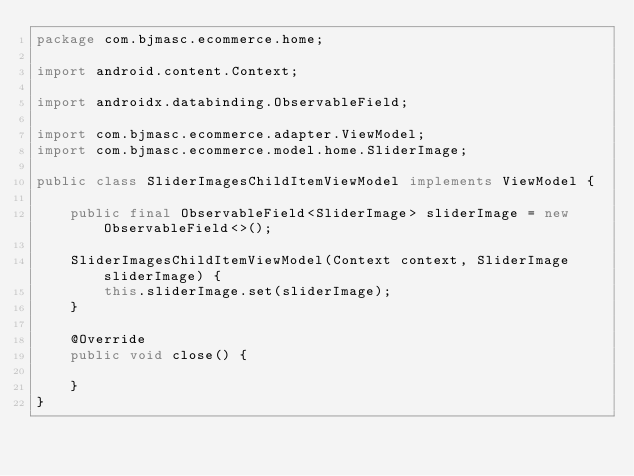Convert code to text. <code><loc_0><loc_0><loc_500><loc_500><_Java_>package com.bjmasc.ecommerce.home;

import android.content.Context;

import androidx.databinding.ObservableField;

import com.bjmasc.ecommerce.adapter.ViewModel;
import com.bjmasc.ecommerce.model.home.SliderImage;

public class SliderImagesChildItemViewModel implements ViewModel {

    public final ObservableField<SliderImage> sliderImage = new ObservableField<>();

    SliderImagesChildItemViewModel(Context context, SliderImage sliderImage) {
        this.sliderImage.set(sliderImage);
    }

    @Override
    public void close() {

    }
}
</code> 